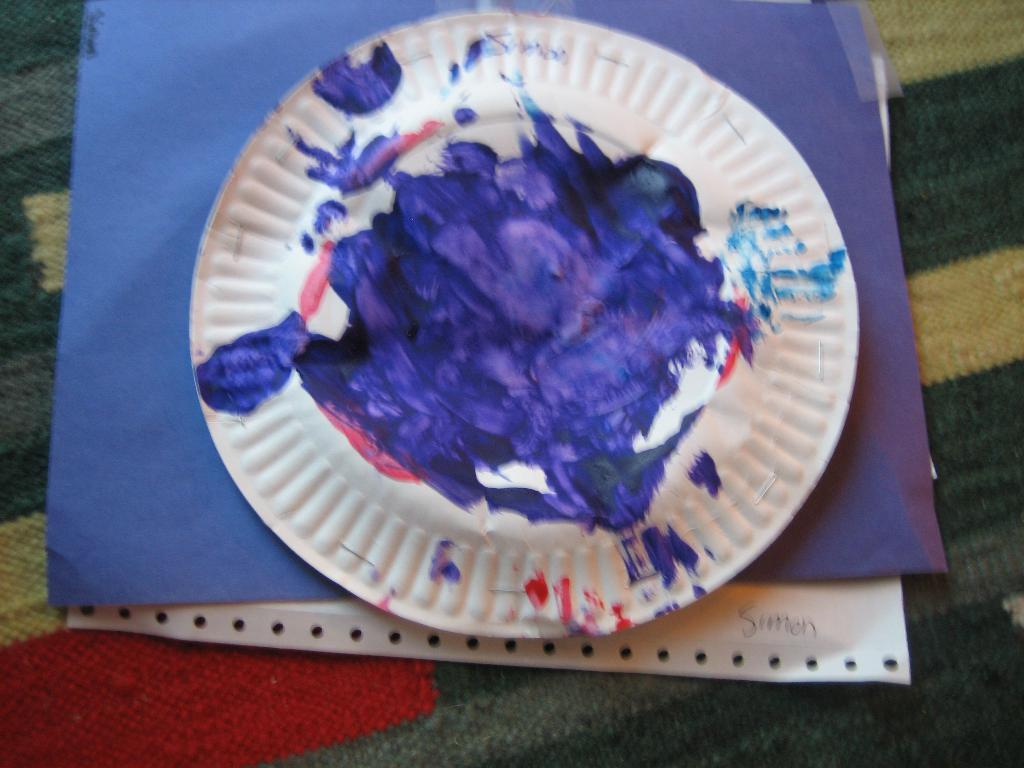What is covering the surface in the image? There is a blanket in the image. What is placed on the blanket? Papers are present on the blanket. Can you describe the plate in the image? There is a white color plate with blue color on it. What type of religion is being practiced in the image? There is no indication of any religious practice in the image. How many brothers are visible in the image? There are no people, let alone brothers, present in the image. 